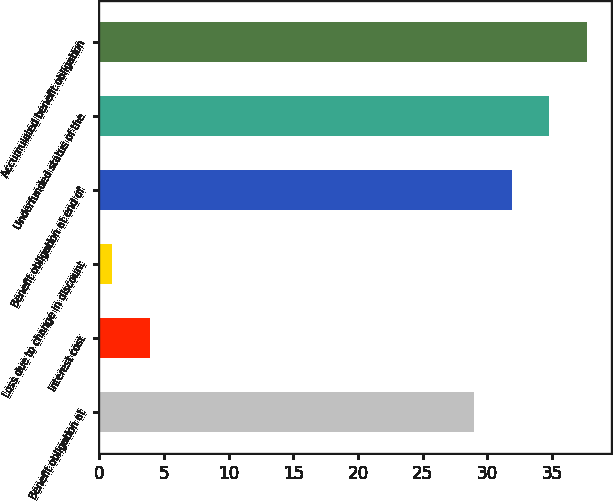Convert chart. <chart><loc_0><loc_0><loc_500><loc_500><bar_chart><fcel>Benefit obligation at<fcel>Interest cost<fcel>Loss due to change in discount<fcel>Benefit obligation at end of<fcel>Underfunded status of the<fcel>Accumulated benefit obligation<nl><fcel>29<fcel>3.9<fcel>1<fcel>31.9<fcel>34.8<fcel>37.7<nl></chart> 